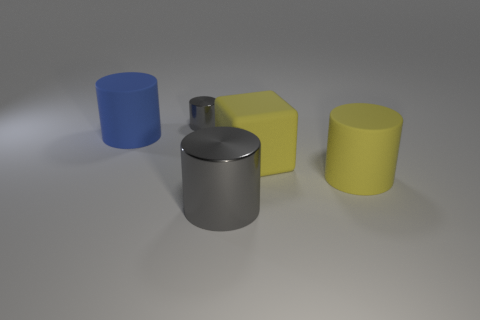Does the shiny cylinder in front of the tiny gray object have the same size as the cylinder on the left side of the small cylinder?
Ensure brevity in your answer.  Yes. Are there more yellow cylinders that are to the left of the small gray metallic object than big metal things behind the blue thing?
Make the answer very short. No. How many other things are the same color as the large shiny thing?
Your response must be concise. 1. Does the matte block have the same color as the large rubber object that is left of the small metallic object?
Offer a very short reply. No. What number of small gray shiny cylinders are in front of the metallic cylinder behind the big yellow cylinder?
Offer a terse response. 0. Is there anything else that is the same material as the tiny cylinder?
Give a very brief answer. Yes. What material is the thing that is on the left side of the gray metal object behind the object in front of the large yellow rubber cylinder made of?
Make the answer very short. Rubber. There is a big cylinder that is to the left of the big yellow block and on the right side of the small gray metallic thing; what is it made of?
Make the answer very short. Metal. How many rubber objects are the same shape as the large gray metal thing?
Provide a short and direct response. 2. What is the size of the gray shiny cylinder in front of the cylinder on the left side of the small gray metallic cylinder?
Provide a succinct answer. Large. 